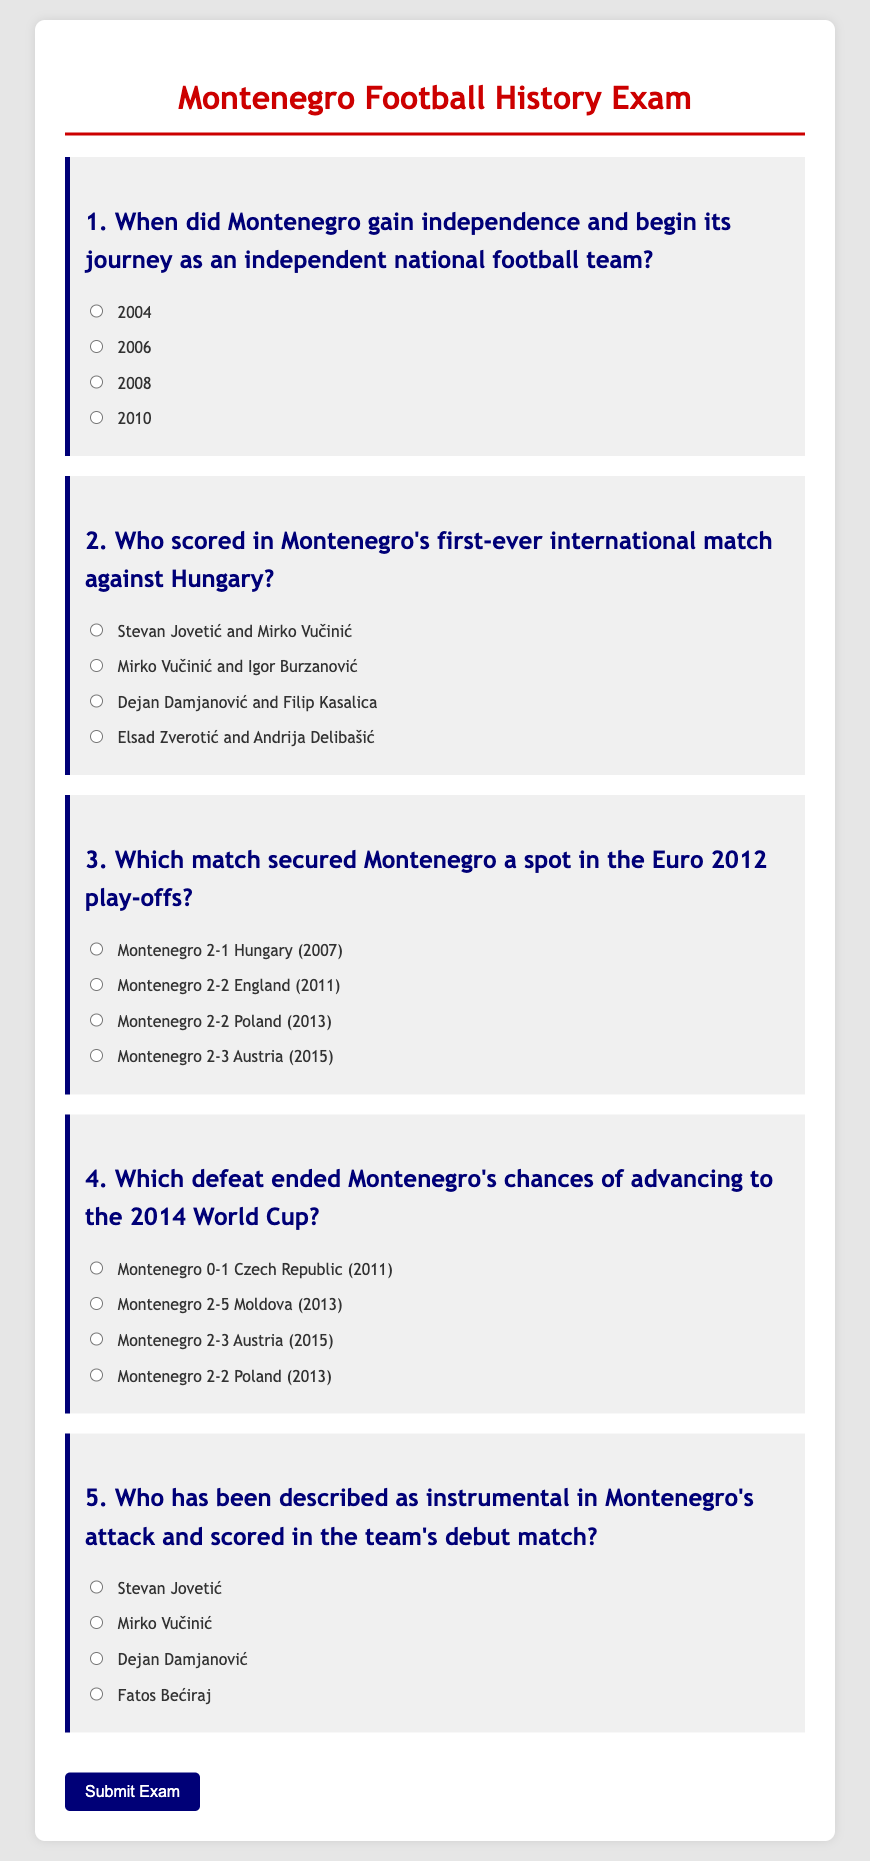When did Montenegro gain independence and begin its journey as an independent national football team? The document states that Montenegro gained independence in 2006, marking its start as an independent national football team.
Answer: 2006 Who scored in Montenegro's first-ever international match against Hungary? The document mentions that Stevan Jovetić and Mirko Vučinić scored in Montenegro's first-ever international match.
Answer: Stevan Jovetić and Mirko Vučinić Which match secured Montenegro a spot in the Euro 2012 play-offs? According to the document, Montenegro secured a spot in the Euro 2012 play-offs with the match Montenegro 2-1 Hungary in 2007.
Answer: Montenegro 2-1 Hungary Which defeat ended Montenegro's chances of advancing to the 2014 World Cup? The document indicates that the defeat Montenegro 0-1 Czech Republic in 2011 ended Montenegro's chances of advancing to the 2014 World Cup.
Answer: Montenegro 0-1 Czech Republic Who has been described as instrumental in Montenegro's attack and scored in the team's debut match? The document identifies Mirko Vučinić as being instrumental in Montenegro's attack and as the player who scored in the team's debut match.
Answer: Mirko Vučinić 